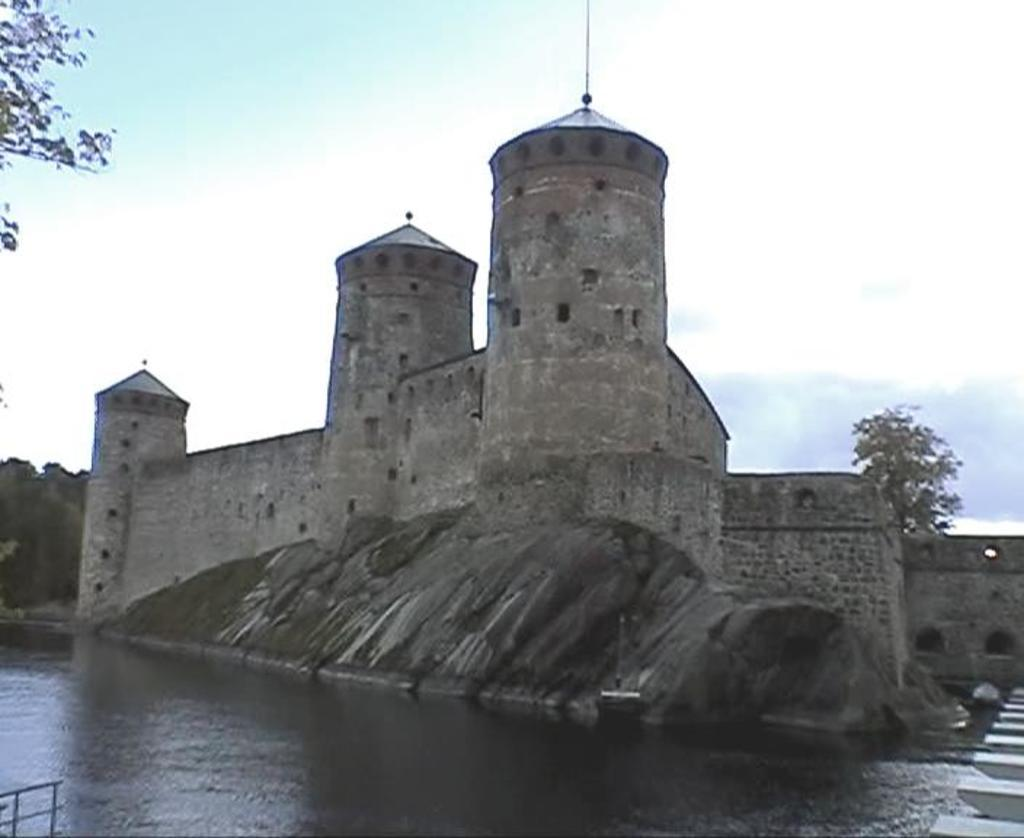What type of structure is present in the image? There is a building in the image. What natural element can be seen in the image? There is water visible in the image. Where is the tree located in the image? There is a tree on the right side of the image, and another tree is in the background of the image. How would you describe the sky in the image? The sky is blue and cloudy. Can you tell me how many eyes are visible on the tree in the image? There are no eyes visible on the tree in the image, as trees do not have eyes. Is there a slope in the image that the building is built on? There is no mention of a slope in the image, and the building appears to be on flat ground. 